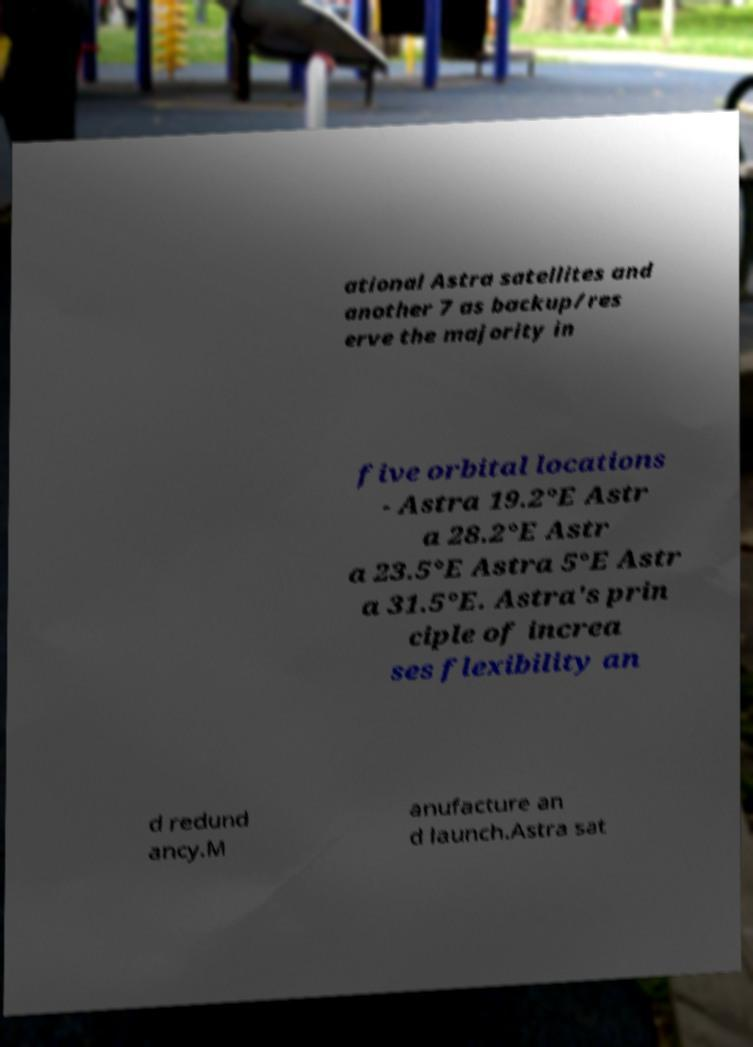Please read and relay the text visible in this image. What does it say? ational Astra satellites and another 7 as backup/res erve the majority in five orbital locations - Astra 19.2°E Astr a 28.2°E Astr a 23.5°E Astra 5°E Astr a 31.5°E. Astra's prin ciple of increa ses flexibility an d redund ancy.M anufacture an d launch.Astra sat 